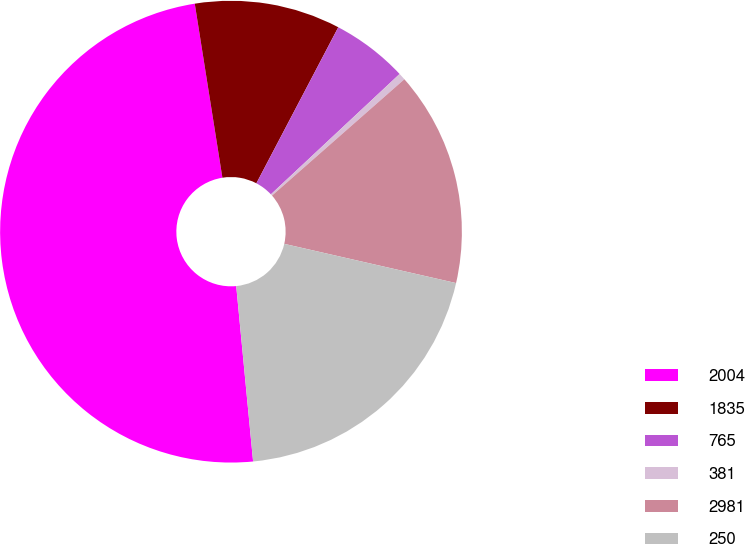<chart> <loc_0><loc_0><loc_500><loc_500><pie_chart><fcel>2004<fcel>1835<fcel>765<fcel>381<fcel>2981<fcel>250<nl><fcel>49.02%<fcel>10.2%<fcel>5.34%<fcel>0.49%<fcel>15.05%<fcel>19.9%<nl></chart> 